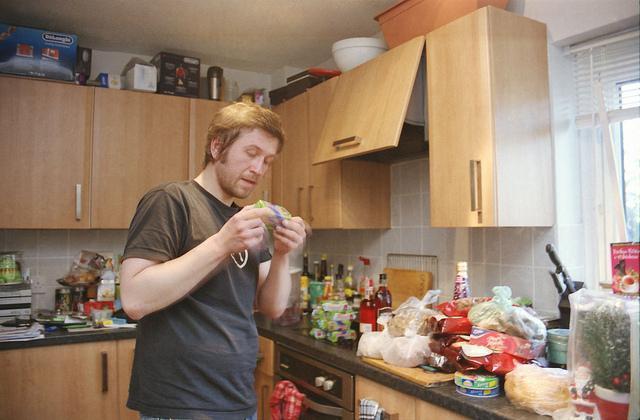How many potted plants are visible?
Give a very brief answer. 1. 